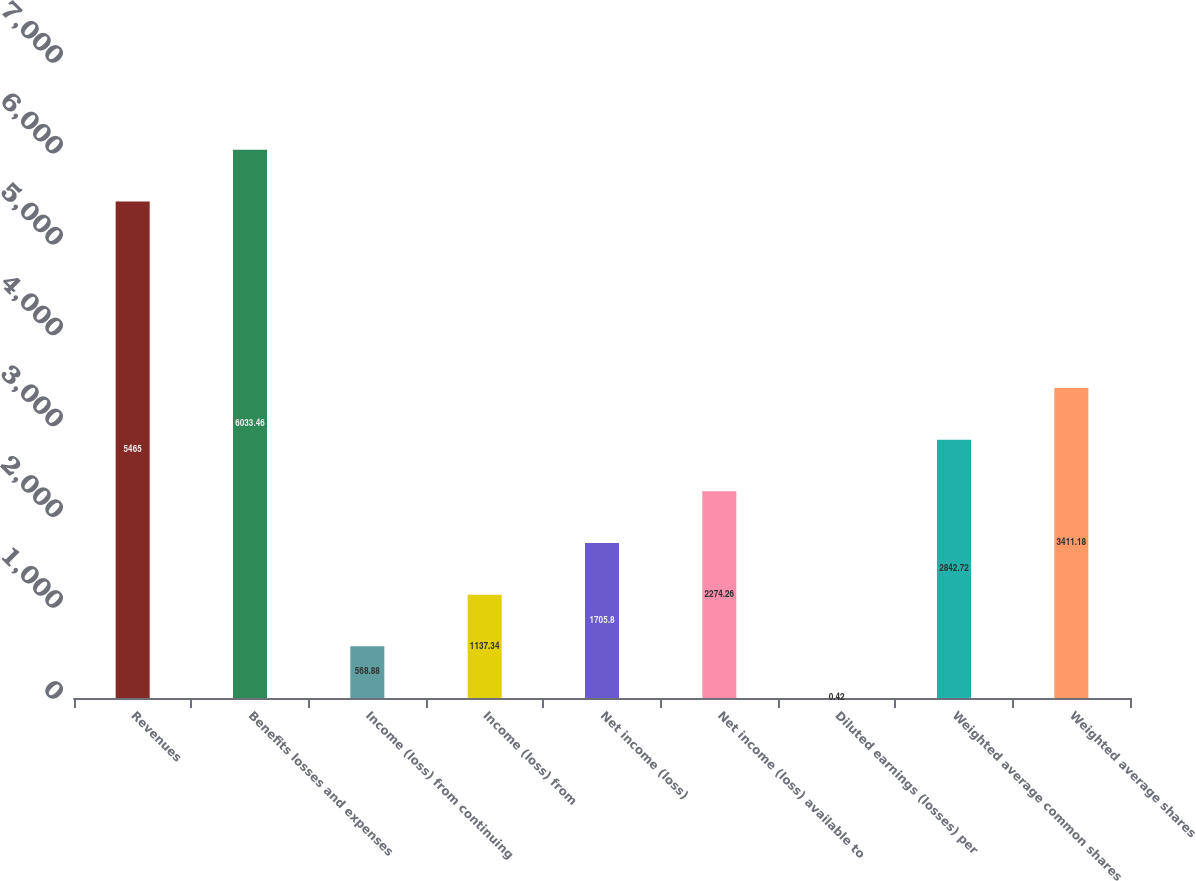<chart> <loc_0><loc_0><loc_500><loc_500><bar_chart><fcel>Revenues<fcel>Benefits losses and expenses<fcel>Income (loss) from continuing<fcel>Income (loss) from<fcel>Net income (loss)<fcel>Net income (loss) available to<fcel>Diluted earnings (losses) per<fcel>Weighted average common shares<fcel>Weighted average shares<nl><fcel>5465<fcel>6033.46<fcel>568.88<fcel>1137.34<fcel>1705.8<fcel>2274.26<fcel>0.42<fcel>2842.72<fcel>3411.18<nl></chart> 